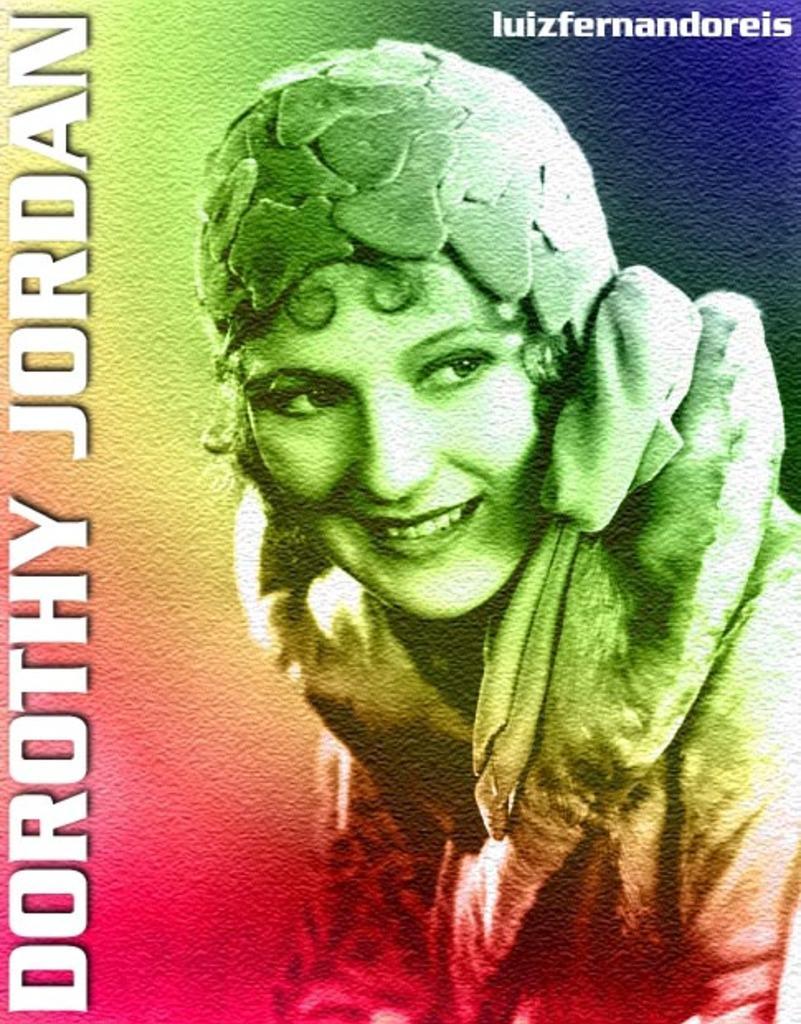Can you describe this image briefly? This image looks like a painting in which I can see a woman, text and a multicolored background. 